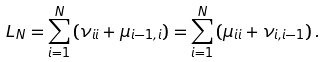Convert formula to latex. <formula><loc_0><loc_0><loc_500><loc_500>L _ { N } = \sum _ { i = 1 } ^ { N } \left ( \nu _ { i i } + \mu _ { i - 1 , i } \right ) = \sum _ { i = 1 } ^ { N } \left ( \mu _ { i i } + \nu _ { i , i - 1 } \right ) .</formula> 